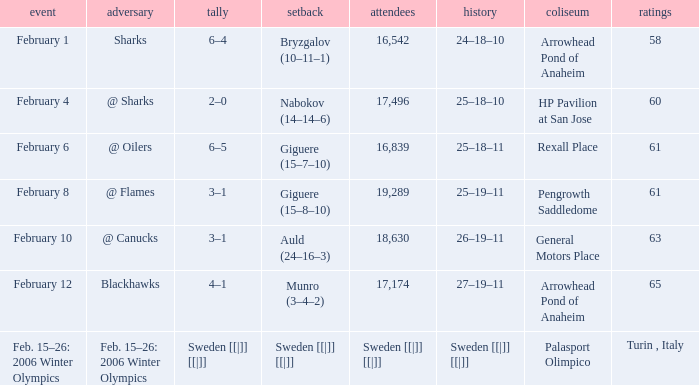What is the points when the score was 3–1, and record was 25–19–11? 61.0. 